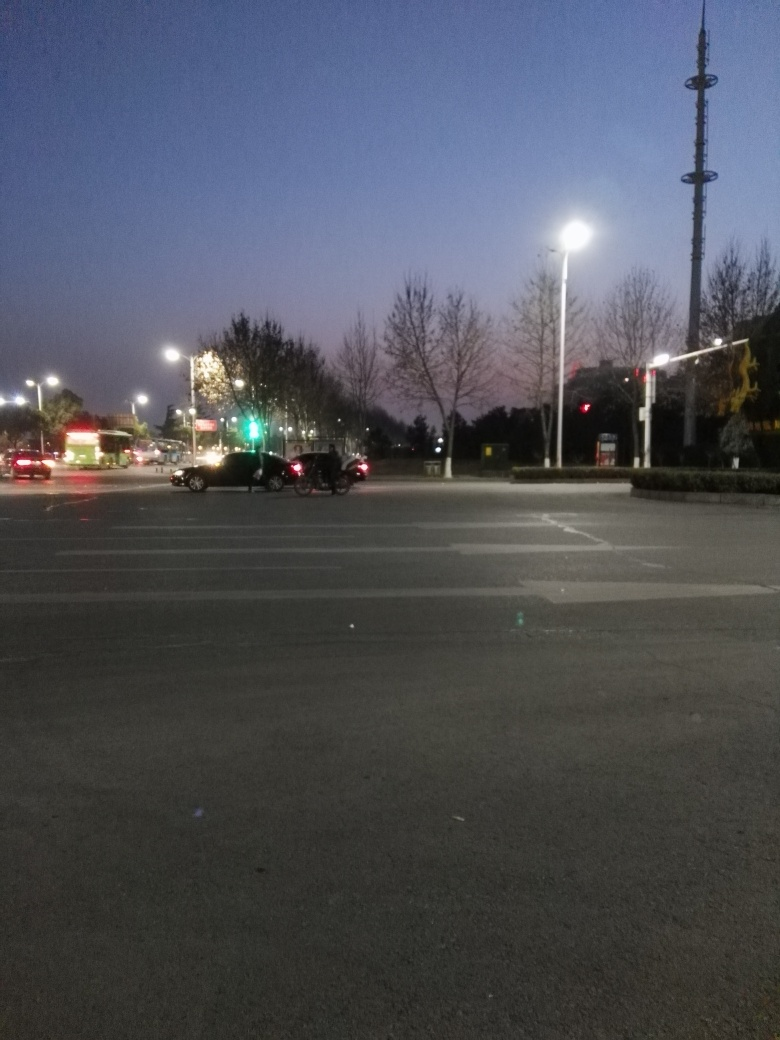Is the quality of this image considered average? The image quality appears to be somewhat average with moderate levels of noise in low light conditions, suggesting it was taken during evening hours or in a region with limited lighting. The photo lacks sharpness and the lighting conditions have impacted the overall clarity and color representation. 